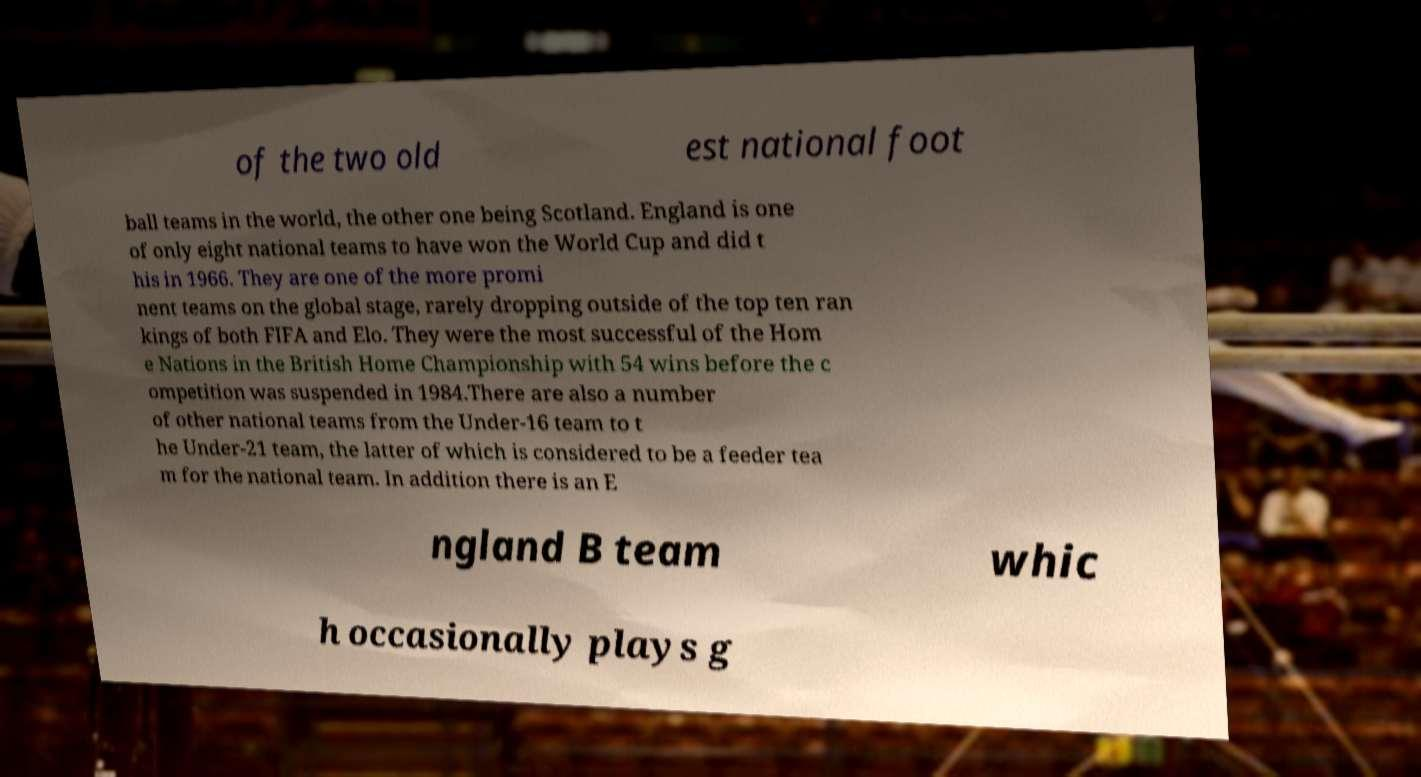Could you assist in decoding the text presented in this image and type it out clearly? of the two old est national foot ball teams in the world, the other one being Scotland. England is one of only eight national teams to have won the World Cup and did t his in 1966. They are one of the more promi nent teams on the global stage, rarely dropping outside of the top ten ran kings of both FIFA and Elo. They were the most successful of the Hom e Nations in the British Home Championship with 54 wins before the c ompetition was suspended in 1984.There are also a number of other national teams from the Under-16 team to t he Under-21 team, the latter of which is considered to be a feeder tea m for the national team. In addition there is an E ngland B team whic h occasionally plays g 